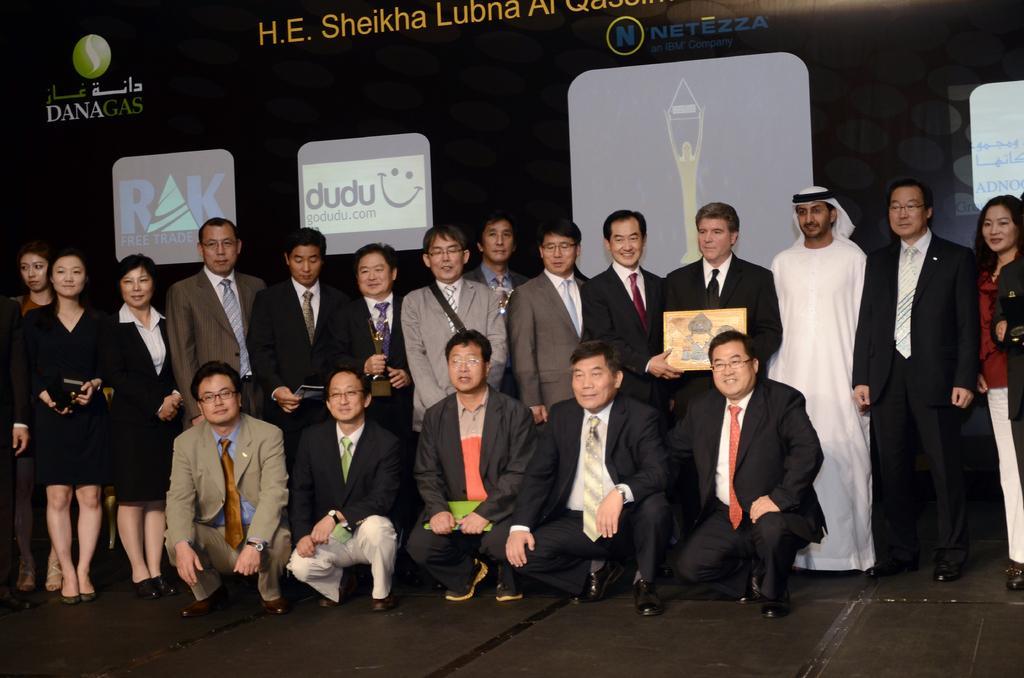Please provide a concise description of this image. In this image we can see some people standing on the stage, two people holding a frame, and two people holding their awards. We can also see some people sitting on their knees front to them. On the backside we can see a board. 